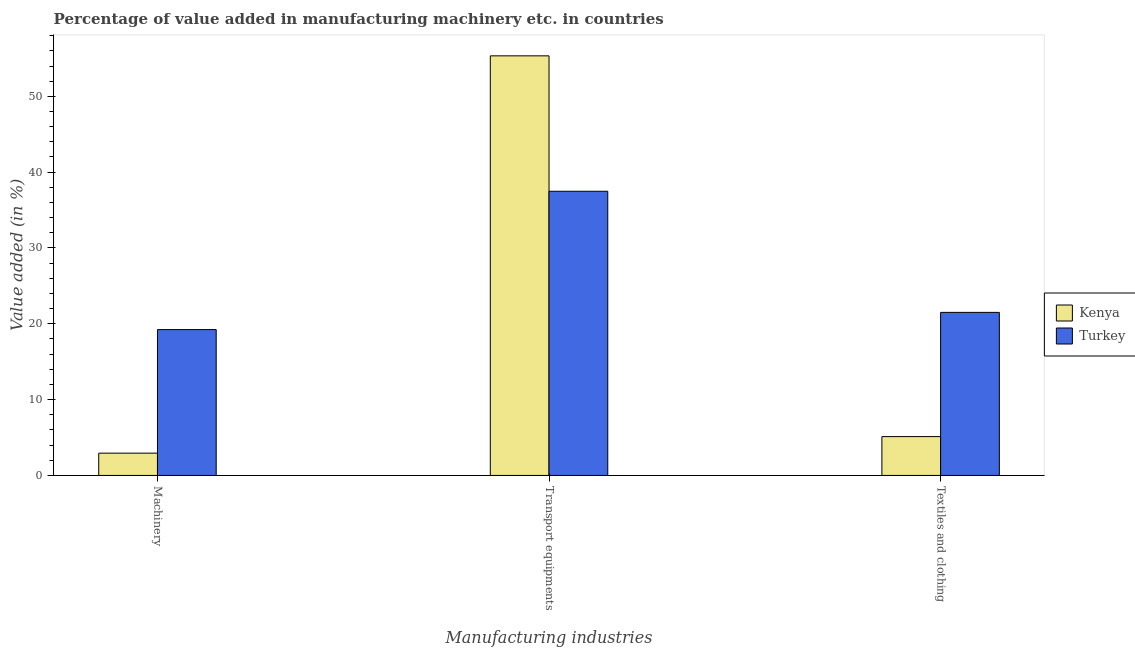How many groups of bars are there?
Give a very brief answer. 3. Are the number of bars per tick equal to the number of legend labels?
Offer a very short reply. Yes. How many bars are there on the 2nd tick from the right?
Give a very brief answer. 2. What is the label of the 2nd group of bars from the left?
Give a very brief answer. Transport equipments. What is the value added in manufacturing transport equipments in Kenya?
Make the answer very short. 55.34. Across all countries, what is the maximum value added in manufacturing transport equipments?
Make the answer very short. 55.34. Across all countries, what is the minimum value added in manufacturing textile and clothing?
Keep it short and to the point. 5.12. In which country was the value added in manufacturing transport equipments minimum?
Provide a succinct answer. Turkey. What is the total value added in manufacturing transport equipments in the graph?
Your answer should be very brief. 92.82. What is the difference between the value added in manufacturing textile and clothing in Kenya and that in Turkey?
Give a very brief answer. -16.38. What is the difference between the value added in manufacturing machinery in Turkey and the value added in manufacturing textile and clothing in Kenya?
Offer a terse response. 14.11. What is the average value added in manufacturing machinery per country?
Offer a terse response. 11.09. What is the difference between the value added in manufacturing textile and clothing and value added in manufacturing machinery in Turkey?
Provide a succinct answer. 2.27. In how many countries, is the value added in manufacturing machinery greater than 18 %?
Provide a succinct answer. 1. What is the ratio of the value added in manufacturing transport equipments in Kenya to that in Turkey?
Ensure brevity in your answer.  1.48. Is the value added in manufacturing machinery in Kenya less than that in Turkey?
Your answer should be very brief. Yes. What is the difference between the highest and the second highest value added in manufacturing transport equipments?
Provide a succinct answer. 17.86. What is the difference between the highest and the lowest value added in manufacturing transport equipments?
Ensure brevity in your answer.  17.86. Is the sum of the value added in manufacturing transport equipments in Kenya and Turkey greater than the maximum value added in manufacturing machinery across all countries?
Your answer should be very brief. Yes. What does the 1st bar from the left in Transport equipments represents?
Your answer should be very brief. Kenya. What does the 1st bar from the right in Transport equipments represents?
Your response must be concise. Turkey. Is it the case that in every country, the sum of the value added in manufacturing machinery and value added in manufacturing transport equipments is greater than the value added in manufacturing textile and clothing?
Make the answer very short. Yes. What is the difference between two consecutive major ticks on the Y-axis?
Give a very brief answer. 10. Are the values on the major ticks of Y-axis written in scientific E-notation?
Ensure brevity in your answer.  No. Does the graph contain any zero values?
Provide a succinct answer. No. How many legend labels are there?
Provide a short and direct response. 2. How are the legend labels stacked?
Keep it short and to the point. Vertical. What is the title of the graph?
Offer a terse response. Percentage of value added in manufacturing machinery etc. in countries. What is the label or title of the X-axis?
Your response must be concise. Manufacturing industries. What is the label or title of the Y-axis?
Keep it short and to the point. Value added (in %). What is the Value added (in %) in Kenya in Machinery?
Offer a terse response. 2.94. What is the Value added (in %) of Turkey in Machinery?
Provide a short and direct response. 19.24. What is the Value added (in %) in Kenya in Transport equipments?
Your answer should be compact. 55.34. What is the Value added (in %) of Turkey in Transport equipments?
Your answer should be very brief. 37.48. What is the Value added (in %) in Kenya in Textiles and clothing?
Your response must be concise. 5.12. What is the Value added (in %) of Turkey in Textiles and clothing?
Ensure brevity in your answer.  21.51. Across all Manufacturing industries, what is the maximum Value added (in %) in Kenya?
Provide a succinct answer. 55.34. Across all Manufacturing industries, what is the maximum Value added (in %) of Turkey?
Offer a terse response. 37.48. Across all Manufacturing industries, what is the minimum Value added (in %) of Kenya?
Give a very brief answer. 2.94. Across all Manufacturing industries, what is the minimum Value added (in %) in Turkey?
Provide a short and direct response. 19.24. What is the total Value added (in %) in Kenya in the graph?
Provide a succinct answer. 63.4. What is the total Value added (in %) of Turkey in the graph?
Your answer should be compact. 78.23. What is the difference between the Value added (in %) of Kenya in Machinery and that in Transport equipments?
Your answer should be very brief. -52.4. What is the difference between the Value added (in %) in Turkey in Machinery and that in Transport equipments?
Offer a very short reply. -18.24. What is the difference between the Value added (in %) in Kenya in Machinery and that in Textiles and clothing?
Provide a short and direct response. -2.18. What is the difference between the Value added (in %) of Turkey in Machinery and that in Textiles and clothing?
Keep it short and to the point. -2.27. What is the difference between the Value added (in %) of Kenya in Transport equipments and that in Textiles and clothing?
Provide a succinct answer. 50.22. What is the difference between the Value added (in %) of Turkey in Transport equipments and that in Textiles and clothing?
Keep it short and to the point. 15.97. What is the difference between the Value added (in %) in Kenya in Machinery and the Value added (in %) in Turkey in Transport equipments?
Offer a terse response. -34.54. What is the difference between the Value added (in %) of Kenya in Machinery and the Value added (in %) of Turkey in Textiles and clothing?
Provide a short and direct response. -18.57. What is the difference between the Value added (in %) of Kenya in Transport equipments and the Value added (in %) of Turkey in Textiles and clothing?
Your answer should be very brief. 33.83. What is the average Value added (in %) in Kenya per Manufacturing industries?
Your answer should be very brief. 21.13. What is the average Value added (in %) in Turkey per Manufacturing industries?
Provide a short and direct response. 26.08. What is the difference between the Value added (in %) of Kenya and Value added (in %) of Turkey in Machinery?
Keep it short and to the point. -16.3. What is the difference between the Value added (in %) in Kenya and Value added (in %) in Turkey in Transport equipments?
Keep it short and to the point. 17.86. What is the difference between the Value added (in %) in Kenya and Value added (in %) in Turkey in Textiles and clothing?
Give a very brief answer. -16.38. What is the ratio of the Value added (in %) in Kenya in Machinery to that in Transport equipments?
Your answer should be compact. 0.05. What is the ratio of the Value added (in %) of Turkey in Machinery to that in Transport equipments?
Give a very brief answer. 0.51. What is the ratio of the Value added (in %) of Kenya in Machinery to that in Textiles and clothing?
Provide a short and direct response. 0.57. What is the ratio of the Value added (in %) in Turkey in Machinery to that in Textiles and clothing?
Your answer should be compact. 0.89. What is the ratio of the Value added (in %) of Kenya in Transport equipments to that in Textiles and clothing?
Your response must be concise. 10.8. What is the ratio of the Value added (in %) in Turkey in Transport equipments to that in Textiles and clothing?
Keep it short and to the point. 1.74. What is the difference between the highest and the second highest Value added (in %) in Kenya?
Your answer should be very brief. 50.22. What is the difference between the highest and the second highest Value added (in %) of Turkey?
Ensure brevity in your answer.  15.97. What is the difference between the highest and the lowest Value added (in %) of Kenya?
Offer a very short reply. 52.4. What is the difference between the highest and the lowest Value added (in %) in Turkey?
Provide a succinct answer. 18.24. 